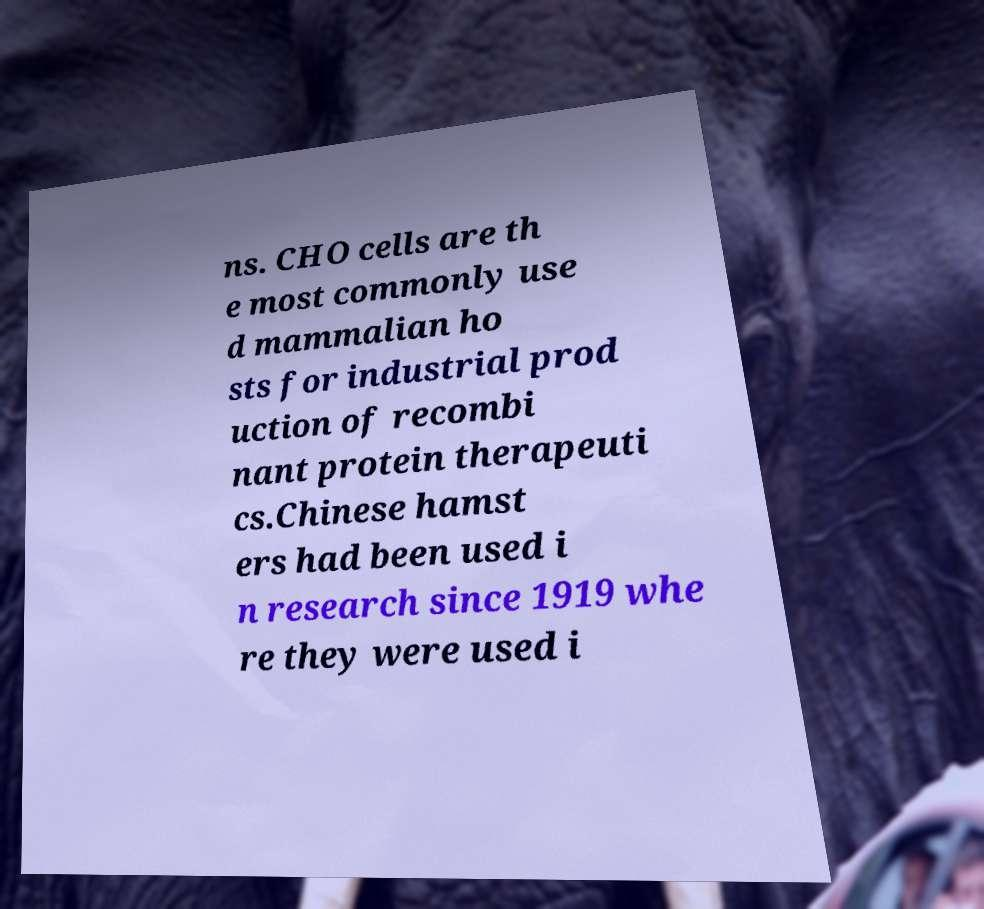Can you read and provide the text displayed in the image?This photo seems to have some interesting text. Can you extract and type it out for me? ns. CHO cells are th e most commonly use d mammalian ho sts for industrial prod uction of recombi nant protein therapeuti cs.Chinese hamst ers had been used i n research since 1919 whe re they were used i 